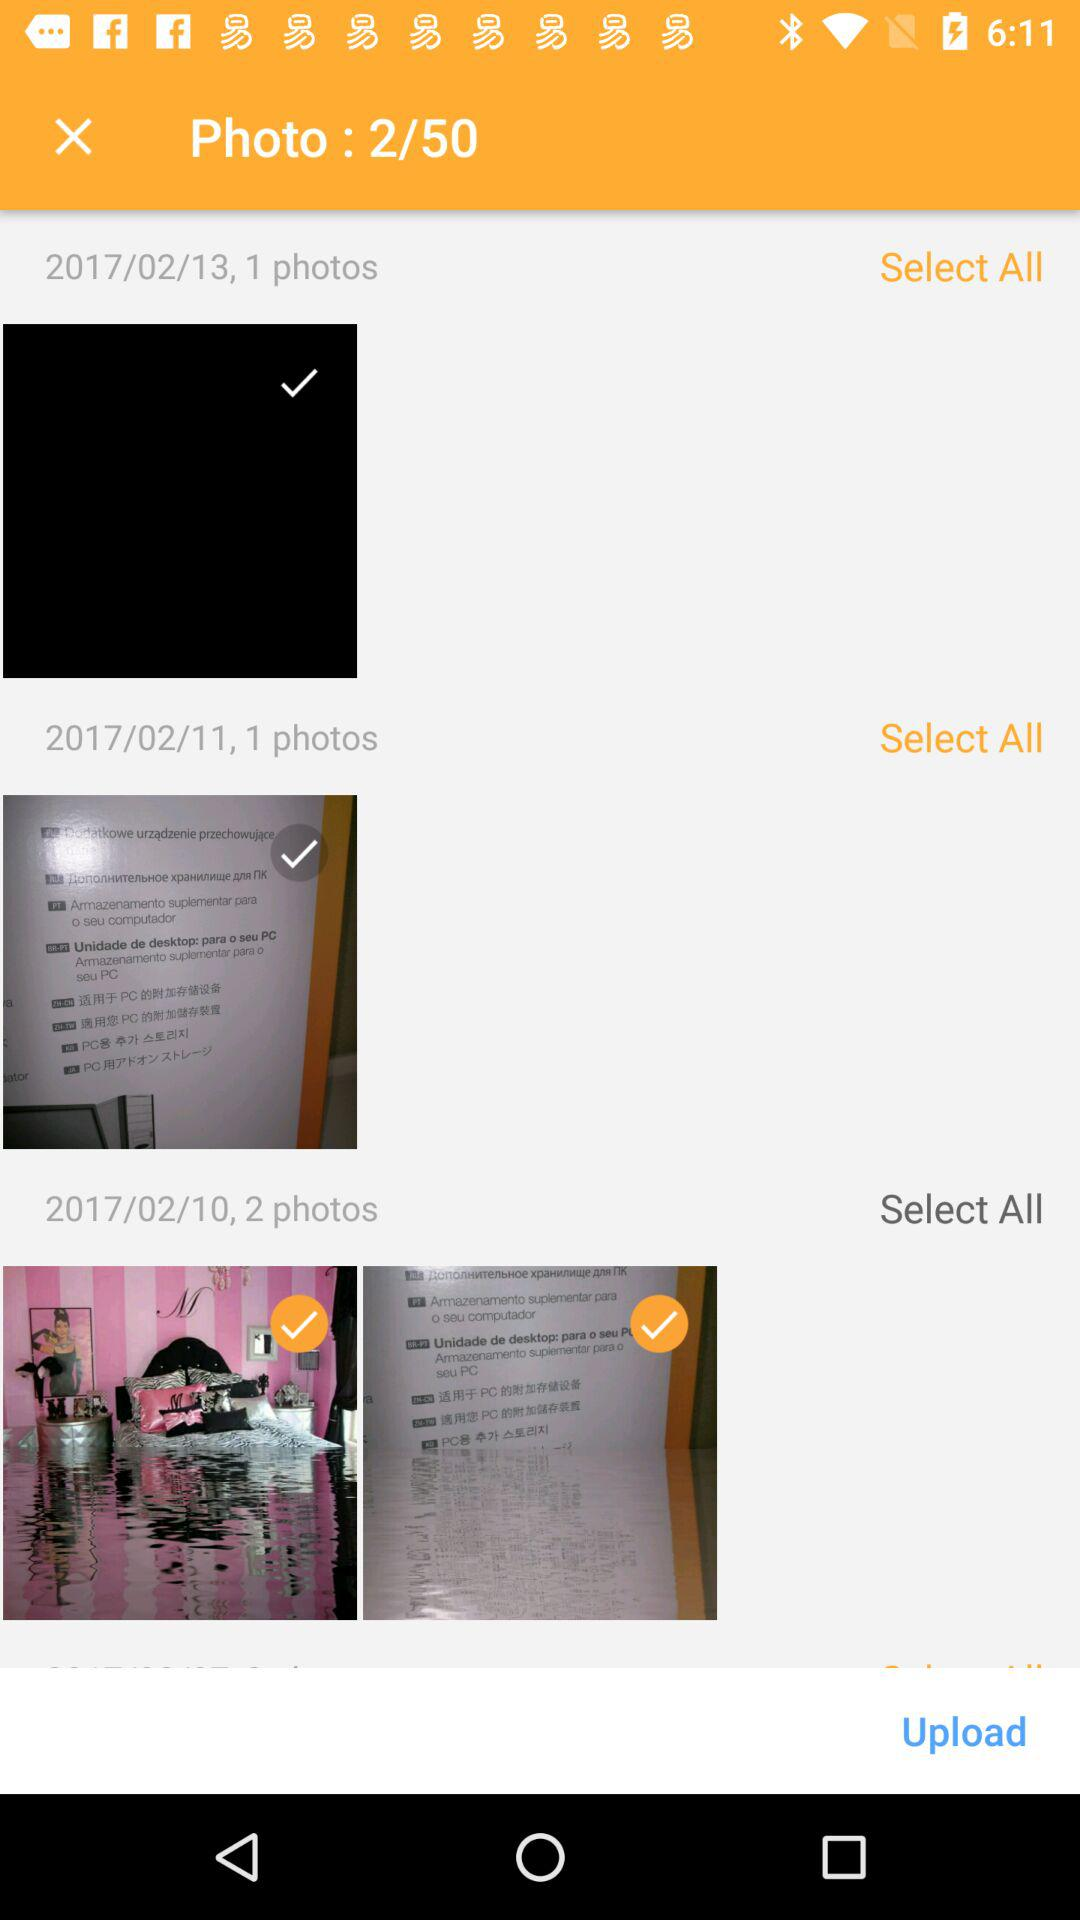How many photos are there for the date 2017/02/10? There are 2 photos. 